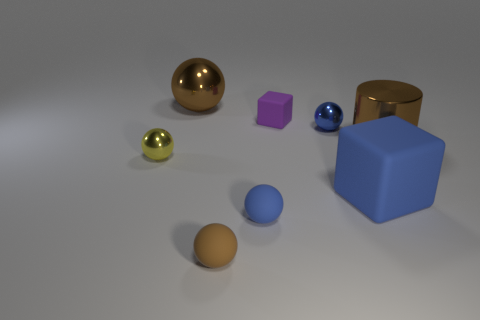Subtract all brown metal balls. How many balls are left? 4 Add 1 tiny green rubber cylinders. How many objects exist? 9 Subtract all yellow spheres. How many spheres are left? 4 Subtract 1 balls. How many balls are left? 4 Subtract all red balls. Subtract all yellow cubes. How many balls are left? 5 Subtract all balls. How many objects are left? 3 Subtract all purple matte objects. Subtract all large gray matte cylinders. How many objects are left? 7 Add 2 blocks. How many blocks are left? 4 Add 6 small blue spheres. How many small blue spheres exist? 8 Subtract 1 purple cubes. How many objects are left? 7 